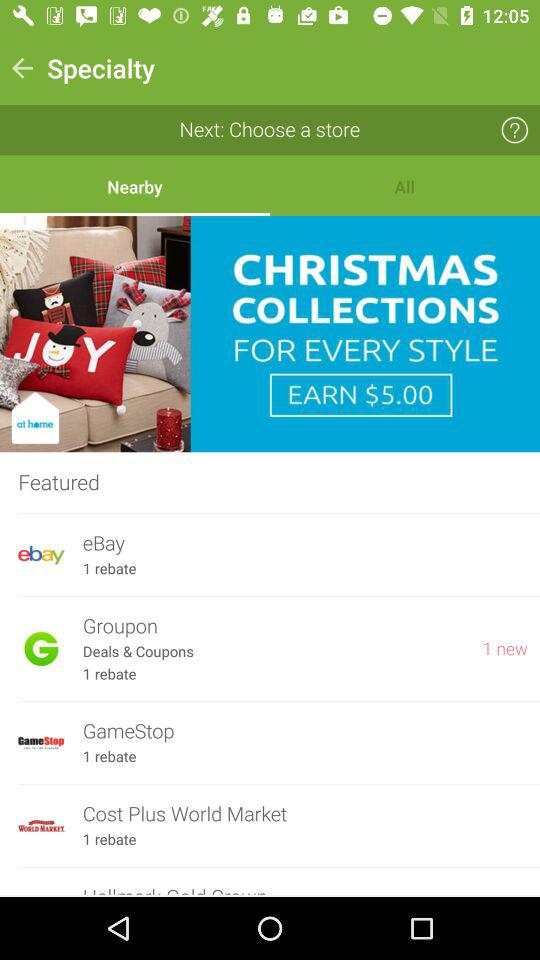Which tab has been selected? The selected tab is "Nearby". 